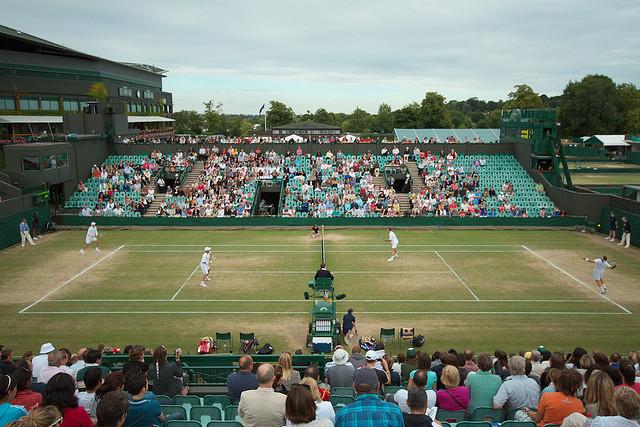What sport is this?
Answer briefly. Tennis. Are there any spectators?
Write a very short answer. Yes. Is this a professional game?
Short answer required. Yes. Which sport is this?
Give a very brief answer. Tennis. 